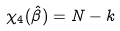Convert formula to latex. <formula><loc_0><loc_0><loc_500><loc_500>\chi _ { 4 } ( \hat { \beta } ) = N - k</formula> 